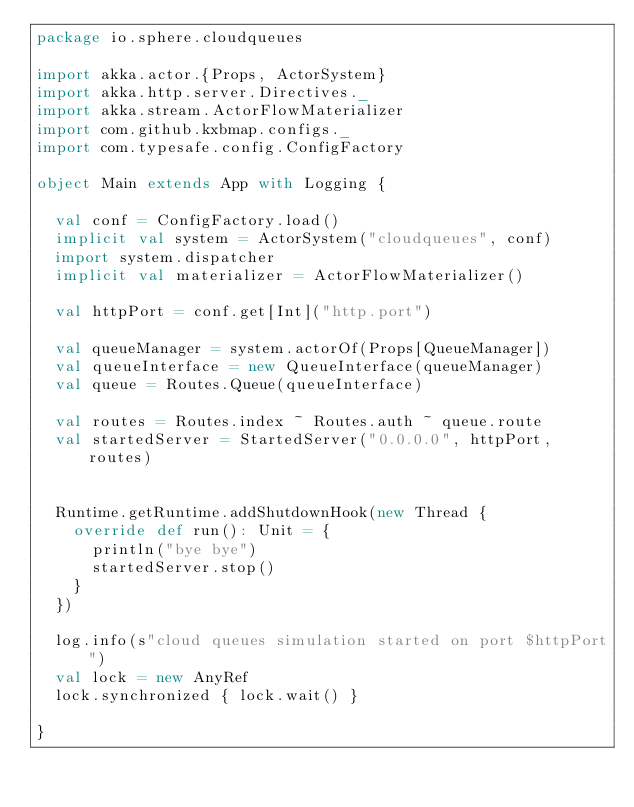Convert code to text. <code><loc_0><loc_0><loc_500><loc_500><_Scala_>package io.sphere.cloudqueues

import akka.actor.{Props, ActorSystem}
import akka.http.server.Directives._
import akka.stream.ActorFlowMaterializer
import com.github.kxbmap.configs._
import com.typesafe.config.ConfigFactory

object Main extends App with Logging {

  val conf = ConfigFactory.load()
  implicit val system = ActorSystem("cloudqueues", conf)
  import system.dispatcher
  implicit val materializer = ActorFlowMaterializer()

  val httpPort = conf.get[Int]("http.port")

  val queueManager = system.actorOf(Props[QueueManager])
  val queueInterface = new QueueInterface(queueManager)
  val queue = Routes.Queue(queueInterface)

  val routes = Routes.index ~ Routes.auth ~ queue.route
  val startedServer = StartedServer("0.0.0.0", httpPort, routes)


  Runtime.getRuntime.addShutdownHook(new Thread {
    override def run(): Unit = {
      println("bye bye")
      startedServer.stop()
    }
  })

  log.info(s"cloud queues simulation started on port $httpPort")
  val lock = new AnyRef
  lock.synchronized { lock.wait() }

}
</code> 